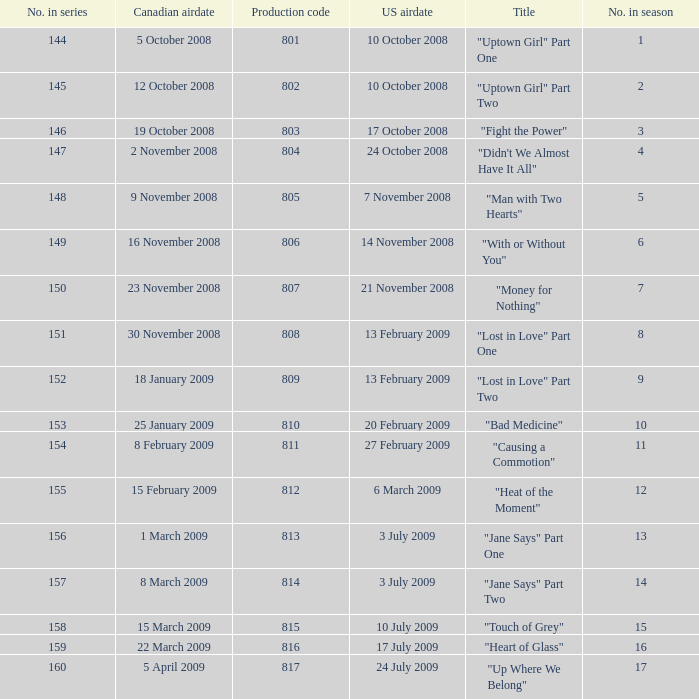What is the latest season number for a show with a production code of 816? 16.0. Could you parse the entire table as a dict? {'header': ['No. in series', 'Canadian airdate', 'Production code', 'US airdate', 'Title', 'No. in season'], 'rows': [['144', '5 October 2008', '801', '10 October 2008', '"Uptown Girl" Part One', '1'], ['145', '12 October 2008', '802', '10 October 2008', '"Uptown Girl" Part Two', '2'], ['146', '19 October 2008', '803', '17 October 2008', '"Fight the Power"', '3'], ['147', '2 November 2008', '804', '24 October 2008', '"Didn\'t We Almost Have It All"', '4'], ['148', '9 November 2008', '805', '7 November 2008', '"Man with Two Hearts"', '5'], ['149', '16 November 2008', '806', '14 November 2008', '"With or Without You"', '6'], ['150', '23 November 2008', '807', '21 November 2008', '"Money for Nothing"', '7'], ['151', '30 November 2008', '808', '13 February 2009', '"Lost in Love" Part One', '8'], ['152', '18 January 2009', '809', '13 February 2009', '"Lost in Love" Part Two', '9'], ['153', '25 January 2009', '810', '20 February 2009', '"Bad Medicine"', '10'], ['154', '8 February 2009', '811', '27 February 2009', '"Causing a Commotion"', '11'], ['155', '15 February 2009', '812', '6 March 2009', '"Heat of the Moment"', '12'], ['156', '1 March 2009', '813', '3 July 2009', '"Jane Says" Part One', '13'], ['157', '8 March 2009', '814', '3 July 2009', '"Jane Says" Part Two', '14'], ['158', '15 March 2009', '815', '10 July 2009', '"Touch of Grey"', '15'], ['159', '22 March 2009', '816', '17 July 2009', '"Heart of Glass"', '16'], ['160', '5 April 2009', '817', '24 July 2009', '"Up Where We Belong"', '17']]} 